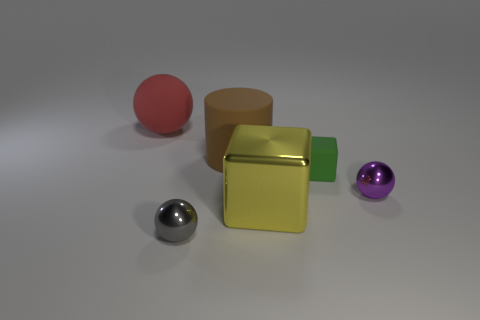Add 2 small blocks. How many objects exist? 8 Subtract all cubes. How many objects are left? 4 Add 1 large spheres. How many large spheres exist? 2 Subtract 0 green cylinders. How many objects are left? 6 Subtract all large brown things. Subtract all red balls. How many objects are left? 4 Add 5 tiny green matte objects. How many tiny green matte objects are left? 6 